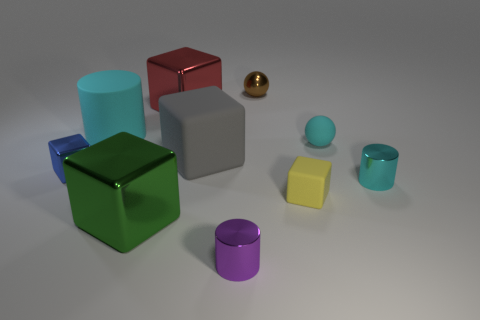How many objects are tiny objects that are to the left of the green shiny thing or green objects?
Give a very brief answer. 2. Is the number of red blocks to the left of the green metal cube greater than the number of cyan rubber cylinders that are right of the big cyan cylinder?
Make the answer very short. No. What number of shiny objects are either brown objects or big cyan objects?
Make the answer very short. 1. There is another cylinder that is the same color as the rubber cylinder; what material is it?
Give a very brief answer. Metal. Is the number of small cylinders in front of the purple shiny thing less than the number of cyan shiny cylinders that are to the left of the large cyan thing?
Your answer should be compact. No. How many objects are yellow rubber cubes or cubes left of the tiny brown thing?
Keep it short and to the point. 5. There is a cylinder that is the same size as the gray rubber thing; what material is it?
Provide a short and direct response. Rubber. Is the big cyan thing made of the same material as the green block?
Provide a short and direct response. No. What is the color of the rubber thing that is both behind the small yellow rubber block and right of the small brown shiny ball?
Offer a very short reply. Cyan. There is a tiny metallic cylinder left of the small cyan cylinder; is it the same color as the large rubber cylinder?
Give a very brief answer. No. 